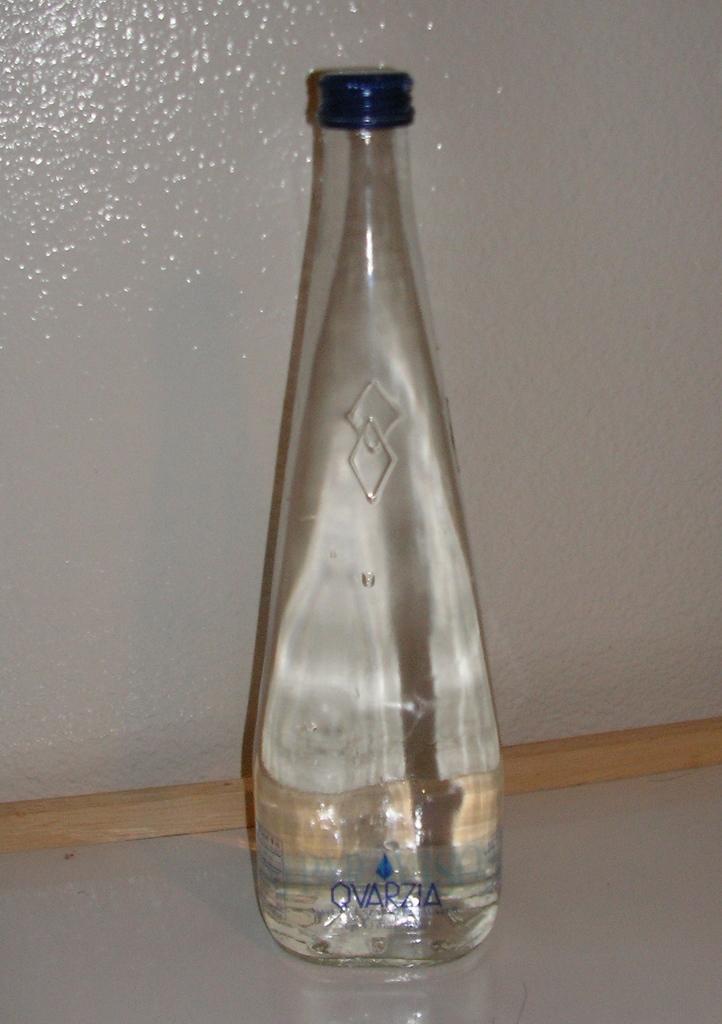In one or two sentences, can you explain what this image depicts? In this picture we can see a bottle and a wooden stick. 